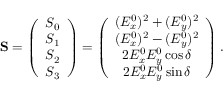<formula> <loc_0><loc_0><loc_500><loc_500>\begin{array} { r } { { S } = \left ( \begin{array} { c } { S _ { 0 } } \\ { S _ { 1 } } \\ { S _ { 2 } } \\ { S _ { 3 } } \end{array} \right ) = \left ( \begin{array} { c } { ( E _ { x } ^ { 0 } ) ^ { 2 } + ( E _ { y } ^ { 0 } ) ^ { 2 } } \\ { ( E _ { x } ^ { 0 } ) ^ { 2 } - ( E _ { y } ^ { 0 } ) ^ { 2 } } \\ { 2 E _ { x } ^ { 0 } E _ { y } ^ { 0 } \cos \delta } \\ { 2 E _ { x } ^ { 0 } E _ { y } ^ { 0 } \sin \delta } \end{array} \right ) . } \end{array}</formula> 